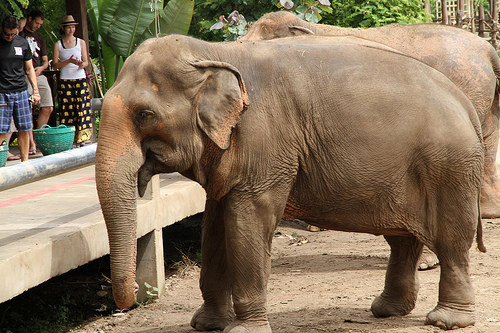Which side of the image is the man on, the left or the right? The man is on the left side of the image. 